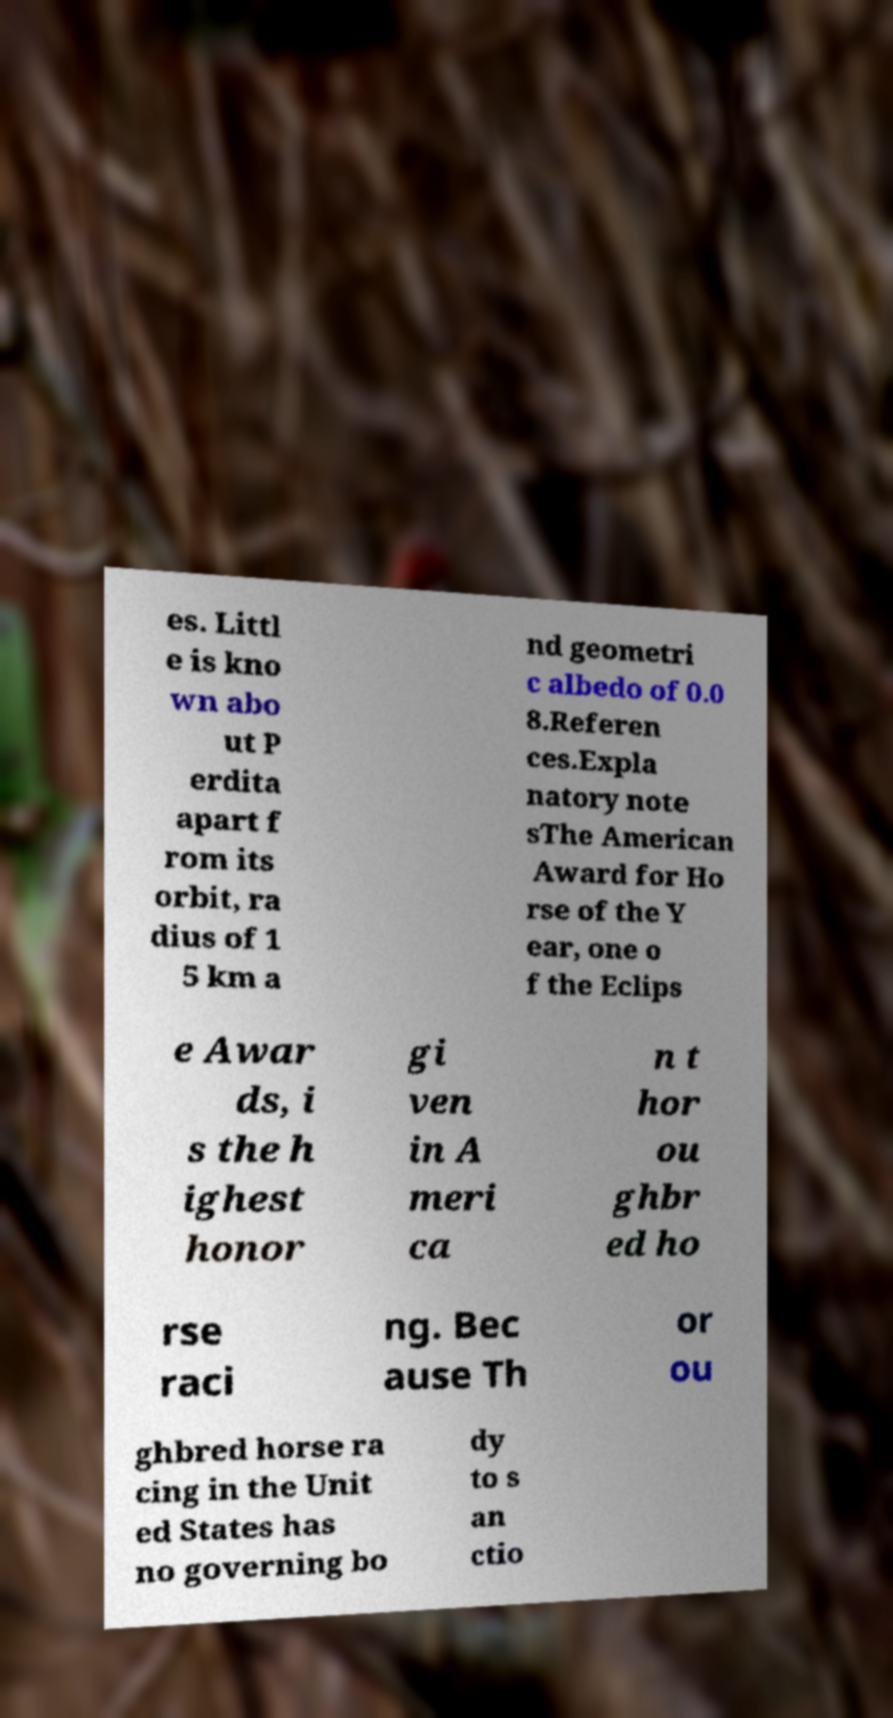For documentation purposes, I need the text within this image transcribed. Could you provide that? es. Littl e is kno wn abo ut P erdita apart f rom its orbit, ra dius of 1 5 km a nd geometri c albedo of 0.0 8.Referen ces.Expla natory note sThe American Award for Ho rse of the Y ear, one o f the Eclips e Awar ds, i s the h ighest honor gi ven in A meri ca n t hor ou ghbr ed ho rse raci ng. Bec ause Th or ou ghbred horse ra cing in the Unit ed States has no governing bo dy to s an ctio 